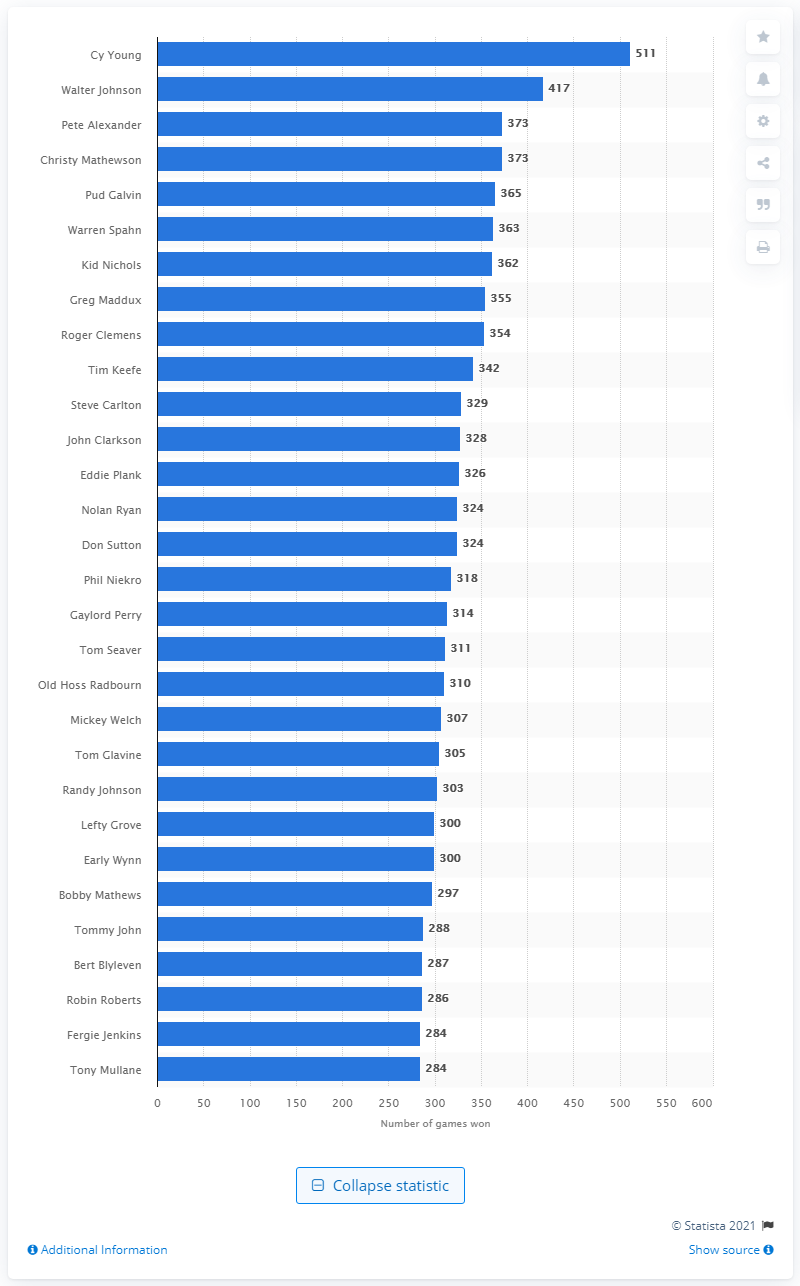Specify some key components in this picture. Cy Young has won 511 games in his illustrious baseball career. 